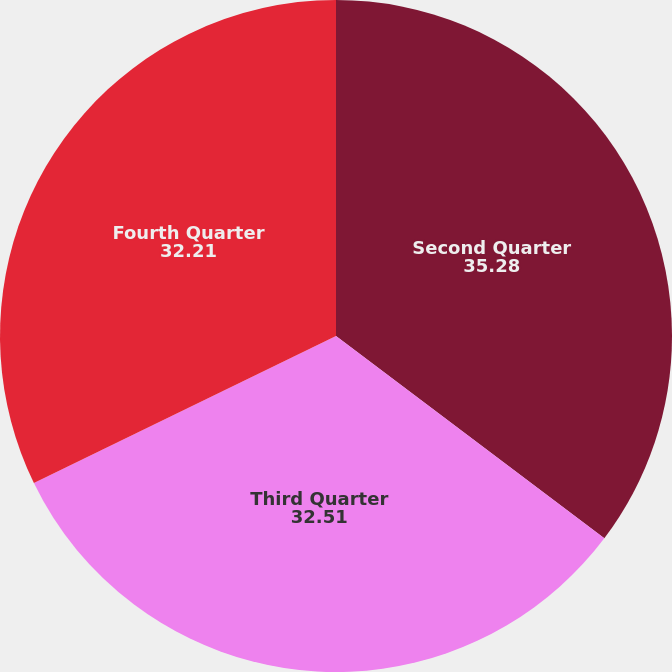<chart> <loc_0><loc_0><loc_500><loc_500><pie_chart><fcel>Second Quarter<fcel>Third Quarter<fcel>Fourth Quarter<nl><fcel>35.28%<fcel>32.51%<fcel>32.21%<nl></chart> 